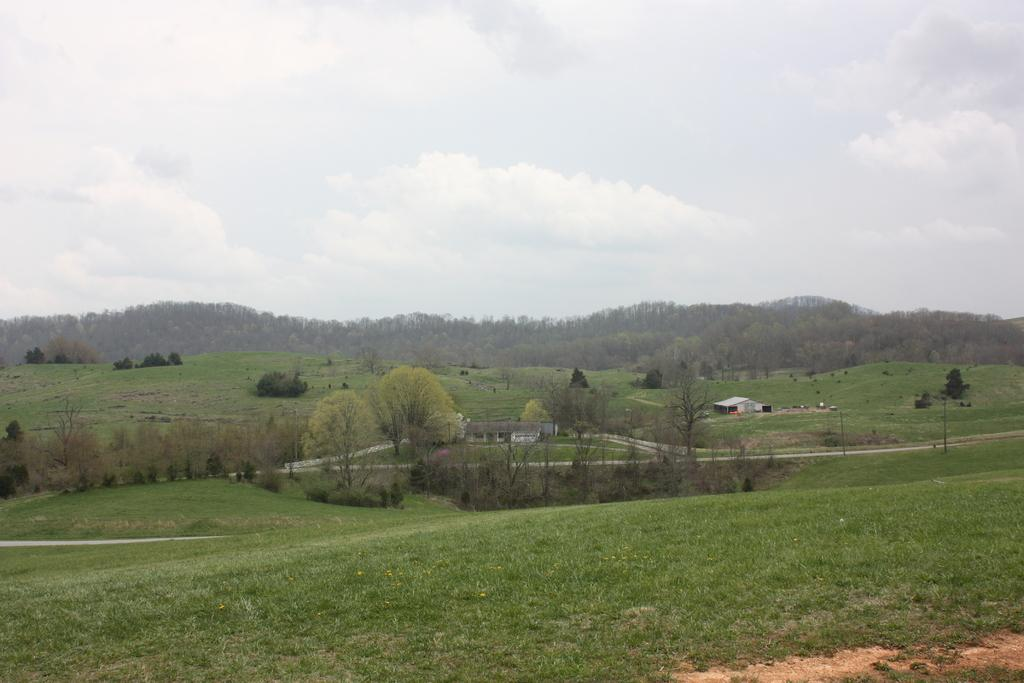What type of structure is present in the image? There is a house in the image. What is another feature that can be seen in the image? There is a road in the image. What type of vegetation is visible in the image? There is grass, trees, and plants visible in the image. What is visible in the sky in the image? The sky is visible in the image, and there are clouds visible. Can you see any snails crawling on the grass in the image? There is no indication of snails present in the image. Is there an army marching down the road in the image? There is no army or any indication of a marching down the road in the image. Where might someone find a toothbrush in the image? There is no toothbrush present in the image. 